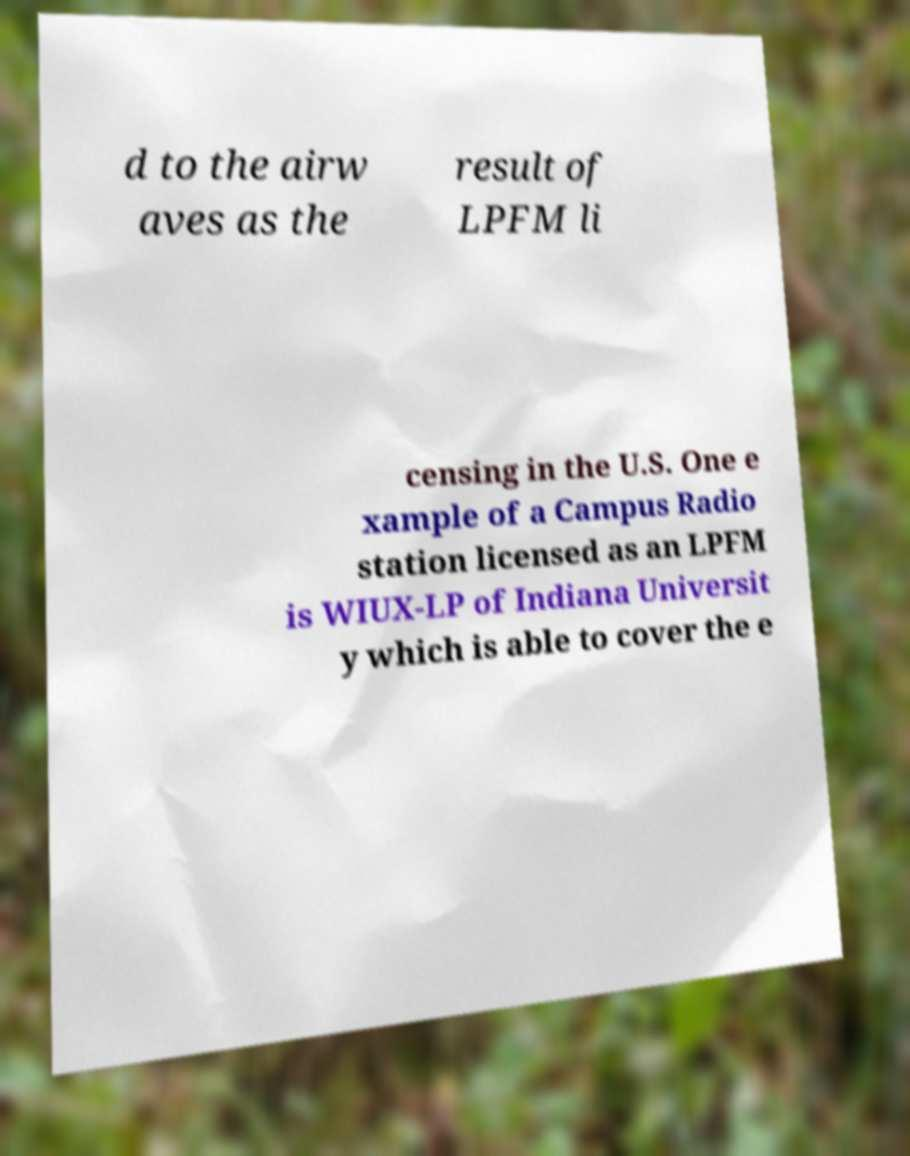Can you accurately transcribe the text from the provided image for me? d to the airw aves as the result of LPFM li censing in the U.S. One e xample of a Campus Radio station licensed as an LPFM is WIUX-LP of Indiana Universit y which is able to cover the e 